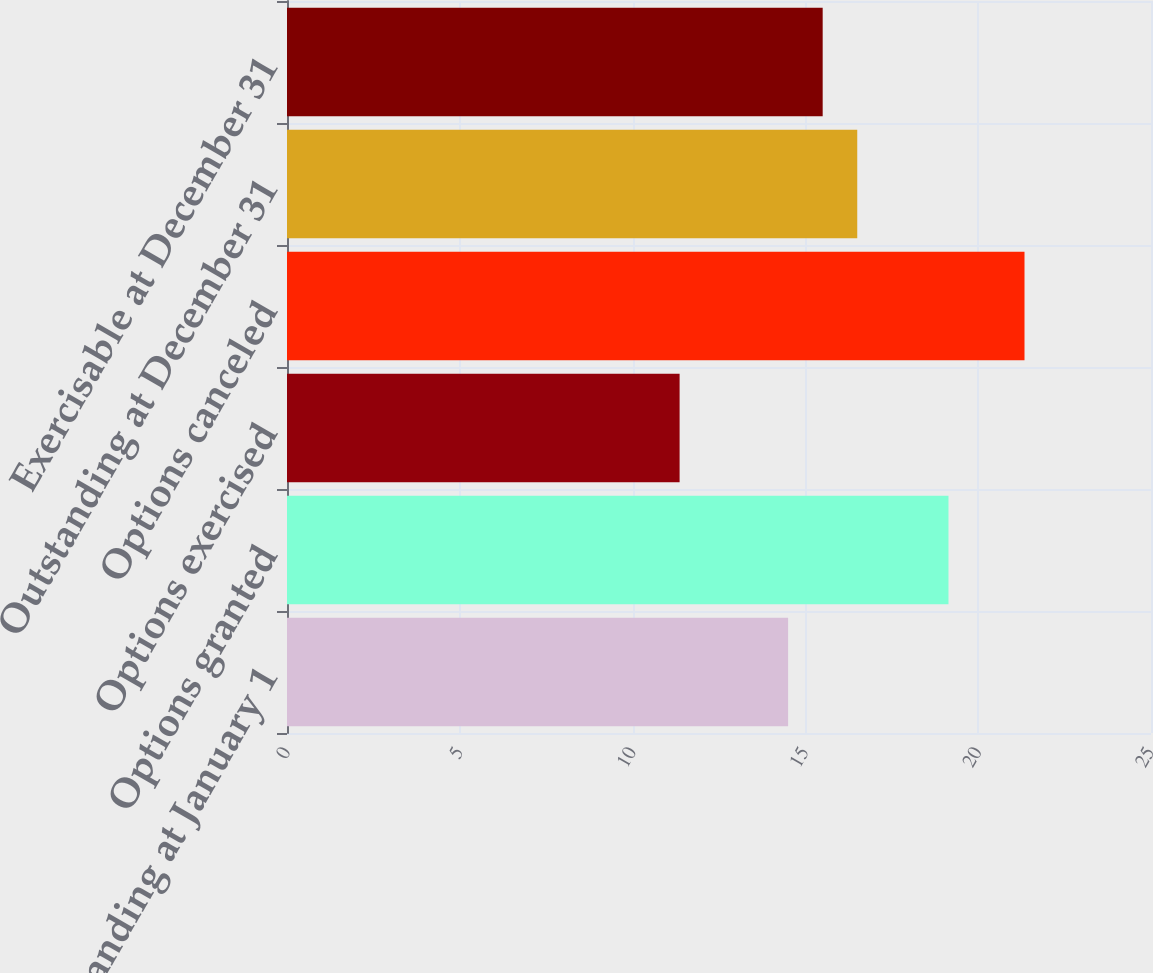<chart> <loc_0><loc_0><loc_500><loc_500><bar_chart><fcel>Outstanding at January 1<fcel>Options granted<fcel>Options exercised<fcel>Options canceled<fcel>Outstanding at December 31<fcel>Exercisable at December 31<nl><fcel>14.5<fcel>19.14<fcel>11.36<fcel>21.34<fcel>16.5<fcel>15.5<nl></chart> 